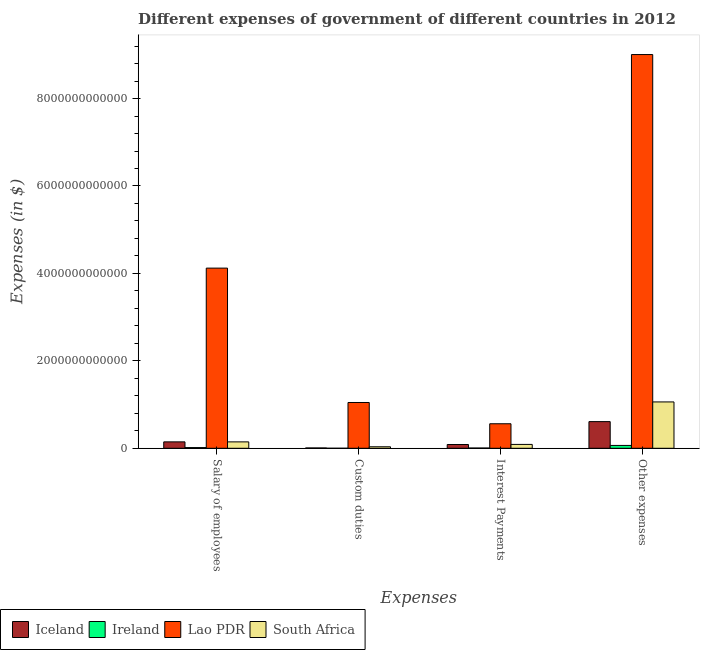How many different coloured bars are there?
Keep it short and to the point. 4. How many groups of bars are there?
Offer a terse response. 4. Are the number of bars per tick equal to the number of legend labels?
Offer a terse response. Yes. What is the label of the 3rd group of bars from the left?
Give a very brief answer. Interest Payments. What is the amount spent on other expenses in Iceland?
Keep it short and to the point. 6.10e+11. Across all countries, what is the maximum amount spent on custom duties?
Offer a terse response. 1.05e+12. Across all countries, what is the minimum amount spent on other expenses?
Offer a very short reply. 6.51e+1. In which country was the amount spent on salary of employees maximum?
Provide a short and direct response. Lao PDR. In which country was the amount spent on interest payments minimum?
Your answer should be very brief. Ireland. What is the total amount spent on custom duties in the graph?
Give a very brief answer. 1.09e+12. What is the difference between the amount spent on custom duties in Iceland and that in Lao PDR?
Provide a short and direct response. -1.04e+12. What is the difference between the amount spent on salary of employees in Iceland and the amount spent on custom duties in Lao PDR?
Offer a terse response. -9.00e+11. What is the average amount spent on other expenses per country?
Provide a short and direct response. 2.69e+12. What is the difference between the amount spent on other expenses and amount spent on custom duties in South Africa?
Your answer should be compact. 1.03e+12. What is the ratio of the amount spent on salary of employees in Lao PDR to that in Iceland?
Offer a very short reply. 28.06. Is the amount spent on other expenses in Iceland less than that in Ireland?
Provide a short and direct response. No. Is the difference between the amount spent on other expenses in Iceland and Ireland greater than the difference between the amount spent on custom duties in Iceland and Ireland?
Give a very brief answer. Yes. What is the difference between the highest and the second highest amount spent on interest payments?
Give a very brief answer. 4.72e+11. What is the difference between the highest and the lowest amount spent on other expenses?
Provide a short and direct response. 8.94e+12. In how many countries, is the amount spent on other expenses greater than the average amount spent on other expenses taken over all countries?
Ensure brevity in your answer.  1. Is the sum of the amount spent on custom duties in Iceland and South Africa greater than the maximum amount spent on interest payments across all countries?
Your answer should be very brief. No. Is it the case that in every country, the sum of the amount spent on other expenses and amount spent on interest payments is greater than the sum of amount spent on salary of employees and amount spent on custom duties?
Your response must be concise. Yes. What does the 4th bar from the left in Interest Payments represents?
Ensure brevity in your answer.  South Africa. What does the 4th bar from the right in Salary of employees represents?
Offer a terse response. Iceland. How many bars are there?
Your response must be concise. 16. How many countries are there in the graph?
Your answer should be compact. 4. What is the difference between two consecutive major ticks on the Y-axis?
Your answer should be very brief. 2.00e+12. Are the values on the major ticks of Y-axis written in scientific E-notation?
Ensure brevity in your answer.  No. Where does the legend appear in the graph?
Provide a short and direct response. Bottom left. How many legend labels are there?
Offer a terse response. 4. What is the title of the graph?
Your answer should be compact. Different expenses of government of different countries in 2012. What is the label or title of the X-axis?
Your answer should be compact. Expenses. What is the label or title of the Y-axis?
Make the answer very short. Expenses (in $). What is the Expenses (in $) of Iceland in Salary of employees?
Your answer should be very brief. 1.47e+11. What is the Expenses (in $) in Ireland in Salary of employees?
Your answer should be compact. 1.60e+1. What is the Expenses (in $) of Lao PDR in Salary of employees?
Provide a short and direct response. 4.12e+12. What is the Expenses (in $) of South Africa in Salary of employees?
Make the answer very short. 1.47e+11. What is the Expenses (in $) in Iceland in Custom duties?
Ensure brevity in your answer.  7.68e+09. What is the Expenses (in $) of Ireland in Custom duties?
Ensure brevity in your answer.  3.74e+07. What is the Expenses (in $) of Lao PDR in Custom duties?
Ensure brevity in your answer.  1.05e+12. What is the Expenses (in $) of South Africa in Custom duties?
Your response must be concise. 3.44e+1. What is the Expenses (in $) of Iceland in Interest Payments?
Your answer should be compact. 8.62e+1. What is the Expenses (in $) of Ireland in Interest Payments?
Your answer should be very brief. 5.89e+09. What is the Expenses (in $) of Lao PDR in Interest Payments?
Provide a short and direct response. 5.61e+11. What is the Expenses (in $) in South Africa in Interest Payments?
Ensure brevity in your answer.  8.85e+1. What is the Expenses (in $) of Iceland in Other expenses?
Your answer should be compact. 6.10e+11. What is the Expenses (in $) of Ireland in Other expenses?
Your answer should be very brief. 6.51e+1. What is the Expenses (in $) of Lao PDR in Other expenses?
Ensure brevity in your answer.  9.01e+12. What is the Expenses (in $) in South Africa in Other expenses?
Offer a very short reply. 1.06e+12. Across all Expenses, what is the maximum Expenses (in $) of Iceland?
Your answer should be very brief. 6.10e+11. Across all Expenses, what is the maximum Expenses (in $) in Ireland?
Provide a short and direct response. 6.51e+1. Across all Expenses, what is the maximum Expenses (in $) in Lao PDR?
Make the answer very short. 9.01e+12. Across all Expenses, what is the maximum Expenses (in $) in South Africa?
Offer a very short reply. 1.06e+12. Across all Expenses, what is the minimum Expenses (in $) of Iceland?
Provide a short and direct response. 7.68e+09. Across all Expenses, what is the minimum Expenses (in $) of Ireland?
Your answer should be very brief. 3.74e+07. Across all Expenses, what is the minimum Expenses (in $) in Lao PDR?
Ensure brevity in your answer.  5.61e+11. Across all Expenses, what is the minimum Expenses (in $) in South Africa?
Your answer should be very brief. 3.44e+1. What is the total Expenses (in $) of Iceland in the graph?
Offer a terse response. 8.51e+11. What is the total Expenses (in $) of Ireland in the graph?
Make the answer very short. 8.71e+1. What is the total Expenses (in $) of Lao PDR in the graph?
Offer a terse response. 1.47e+13. What is the total Expenses (in $) of South Africa in the graph?
Offer a terse response. 1.33e+12. What is the difference between the Expenses (in $) in Iceland in Salary of employees and that in Custom duties?
Your response must be concise. 1.39e+11. What is the difference between the Expenses (in $) of Ireland in Salary of employees and that in Custom duties?
Your answer should be very brief. 1.60e+1. What is the difference between the Expenses (in $) of Lao PDR in Salary of employees and that in Custom duties?
Your answer should be very brief. 3.07e+12. What is the difference between the Expenses (in $) of South Africa in Salary of employees and that in Custom duties?
Your response must be concise. 1.12e+11. What is the difference between the Expenses (in $) in Iceland in Salary of employees and that in Interest Payments?
Make the answer very short. 6.07e+1. What is the difference between the Expenses (in $) in Ireland in Salary of employees and that in Interest Payments?
Provide a short and direct response. 1.02e+1. What is the difference between the Expenses (in $) of Lao PDR in Salary of employees and that in Interest Payments?
Provide a succinct answer. 3.56e+12. What is the difference between the Expenses (in $) of South Africa in Salary of employees and that in Interest Payments?
Offer a very short reply. 5.80e+1. What is the difference between the Expenses (in $) in Iceland in Salary of employees and that in Other expenses?
Provide a succinct answer. -4.63e+11. What is the difference between the Expenses (in $) in Ireland in Salary of employees and that in Other expenses?
Offer a very short reply. -4.91e+1. What is the difference between the Expenses (in $) in Lao PDR in Salary of employees and that in Other expenses?
Provide a short and direct response. -4.89e+12. What is the difference between the Expenses (in $) in South Africa in Salary of employees and that in Other expenses?
Offer a very short reply. -9.14e+11. What is the difference between the Expenses (in $) in Iceland in Custom duties and that in Interest Payments?
Provide a succinct answer. -7.85e+1. What is the difference between the Expenses (in $) in Ireland in Custom duties and that in Interest Payments?
Offer a very short reply. -5.85e+09. What is the difference between the Expenses (in $) of Lao PDR in Custom duties and that in Interest Payments?
Give a very brief answer. 4.86e+11. What is the difference between the Expenses (in $) of South Africa in Custom duties and that in Interest Payments?
Offer a very short reply. -5.41e+1. What is the difference between the Expenses (in $) in Iceland in Custom duties and that in Other expenses?
Your answer should be very brief. -6.02e+11. What is the difference between the Expenses (in $) of Ireland in Custom duties and that in Other expenses?
Offer a very short reply. -6.51e+1. What is the difference between the Expenses (in $) of Lao PDR in Custom duties and that in Other expenses?
Your answer should be compact. -7.96e+12. What is the difference between the Expenses (in $) in South Africa in Custom duties and that in Other expenses?
Your answer should be very brief. -1.03e+12. What is the difference between the Expenses (in $) of Iceland in Interest Payments and that in Other expenses?
Keep it short and to the point. -5.24e+11. What is the difference between the Expenses (in $) of Ireland in Interest Payments and that in Other expenses?
Provide a succinct answer. -5.92e+1. What is the difference between the Expenses (in $) of Lao PDR in Interest Payments and that in Other expenses?
Your answer should be compact. -8.45e+12. What is the difference between the Expenses (in $) of South Africa in Interest Payments and that in Other expenses?
Provide a succinct answer. -9.72e+11. What is the difference between the Expenses (in $) of Iceland in Salary of employees and the Expenses (in $) of Ireland in Custom duties?
Offer a very short reply. 1.47e+11. What is the difference between the Expenses (in $) of Iceland in Salary of employees and the Expenses (in $) of Lao PDR in Custom duties?
Offer a very short reply. -9.00e+11. What is the difference between the Expenses (in $) of Iceland in Salary of employees and the Expenses (in $) of South Africa in Custom duties?
Your answer should be very brief. 1.12e+11. What is the difference between the Expenses (in $) of Ireland in Salary of employees and the Expenses (in $) of Lao PDR in Custom duties?
Make the answer very short. -1.03e+12. What is the difference between the Expenses (in $) of Ireland in Salary of employees and the Expenses (in $) of South Africa in Custom duties?
Your answer should be compact. -1.83e+1. What is the difference between the Expenses (in $) of Lao PDR in Salary of employees and the Expenses (in $) of South Africa in Custom duties?
Keep it short and to the point. 4.09e+12. What is the difference between the Expenses (in $) of Iceland in Salary of employees and the Expenses (in $) of Ireland in Interest Payments?
Provide a short and direct response. 1.41e+11. What is the difference between the Expenses (in $) in Iceland in Salary of employees and the Expenses (in $) in Lao PDR in Interest Payments?
Offer a terse response. -4.14e+11. What is the difference between the Expenses (in $) in Iceland in Salary of employees and the Expenses (in $) in South Africa in Interest Payments?
Your response must be concise. 5.84e+1. What is the difference between the Expenses (in $) in Ireland in Salary of employees and the Expenses (in $) in Lao PDR in Interest Payments?
Offer a terse response. -5.45e+11. What is the difference between the Expenses (in $) in Ireland in Salary of employees and the Expenses (in $) in South Africa in Interest Payments?
Your response must be concise. -7.25e+1. What is the difference between the Expenses (in $) in Lao PDR in Salary of employees and the Expenses (in $) in South Africa in Interest Payments?
Keep it short and to the point. 4.03e+12. What is the difference between the Expenses (in $) in Iceland in Salary of employees and the Expenses (in $) in Ireland in Other expenses?
Your answer should be compact. 8.18e+1. What is the difference between the Expenses (in $) of Iceland in Salary of employees and the Expenses (in $) of Lao PDR in Other expenses?
Your answer should be compact. -8.86e+12. What is the difference between the Expenses (in $) in Iceland in Salary of employees and the Expenses (in $) in South Africa in Other expenses?
Offer a terse response. -9.14e+11. What is the difference between the Expenses (in $) of Ireland in Salary of employees and the Expenses (in $) of Lao PDR in Other expenses?
Provide a succinct answer. -8.99e+12. What is the difference between the Expenses (in $) in Ireland in Salary of employees and the Expenses (in $) in South Africa in Other expenses?
Make the answer very short. -1.04e+12. What is the difference between the Expenses (in $) of Lao PDR in Salary of employees and the Expenses (in $) of South Africa in Other expenses?
Your answer should be compact. 3.06e+12. What is the difference between the Expenses (in $) in Iceland in Custom duties and the Expenses (in $) in Ireland in Interest Payments?
Offer a terse response. 1.79e+09. What is the difference between the Expenses (in $) of Iceland in Custom duties and the Expenses (in $) of Lao PDR in Interest Payments?
Your response must be concise. -5.53e+11. What is the difference between the Expenses (in $) in Iceland in Custom duties and the Expenses (in $) in South Africa in Interest Payments?
Your answer should be compact. -8.08e+1. What is the difference between the Expenses (in $) of Ireland in Custom duties and the Expenses (in $) of Lao PDR in Interest Payments?
Offer a terse response. -5.61e+11. What is the difference between the Expenses (in $) in Ireland in Custom duties and the Expenses (in $) in South Africa in Interest Payments?
Keep it short and to the point. -8.85e+1. What is the difference between the Expenses (in $) of Lao PDR in Custom duties and the Expenses (in $) of South Africa in Interest Payments?
Your response must be concise. 9.59e+11. What is the difference between the Expenses (in $) of Iceland in Custom duties and the Expenses (in $) of Ireland in Other expenses?
Your answer should be compact. -5.74e+1. What is the difference between the Expenses (in $) in Iceland in Custom duties and the Expenses (in $) in Lao PDR in Other expenses?
Offer a terse response. -9.00e+12. What is the difference between the Expenses (in $) of Iceland in Custom duties and the Expenses (in $) of South Africa in Other expenses?
Give a very brief answer. -1.05e+12. What is the difference between the Expenses (in $) in Ireland in Custom duties and the Expenses (in $) in Lao PDR in Other expenses?
Offer a very short reply. -9.01e+12. What is the difference between the Expenses (in $) in Ireland in Custom duties and the Expenses (in $) in South Africa in Other expenses?
Your answer should be very brief. -1.06e+12. What is the difference between the Expenses (in $) of Lao PDR in Custom duties and the Expenses (in $) of South Africa in Other expenses?
Give a very brief answer. -1.31e+1. What is the difference between the Expenses (in $) in Iceland in Interest Payments and the Expenses (in $) in Ireland in Other expenses?
Provide a succinct answer. 2.11e+1. What is the difference between the Expenses (in $) of Iceland in Interest Payments and the Expenses (in $) of Lao PDR in Other expenses?
Offer a very short reply. -8.92e+12. What is the difference between the Expenses (in $) in Iceland in Interest Payments and the Expenses (in $) in South Africa in Other expenses?
Provide a succinct answer. -9.74e+11. What is the difference between the Expenses (in $) of Ireland in Interest Payments and the Expenses (in $) of Lao PDR in Other expenses?
Make the answer very short. -9.00e+12. What is the difference between the Expenses (in $) in Ireland in Interest Payments and the Expenses (in $) in South Africa in Other expenses?
Your answer should be compact. -1.05e+12. What is the difference between the Expenses (in $) in Lao PDR in Interest Payments and the Expenses (in $) in South Africa in Other expenses?
Offer a very short reply. -5.00e+11. What is the average Expenses (in $) in Iceland per Expenses?
Provide a short and direct response. 2.13e+11. What is the average Expenses (in $) of Ireland per Expenses?
Provide a short and direct response. 2.18e+1. What is the average Expenses (in $) in Lao PDR per Expenses?
Keep it short and to the point. 3.68e+12. What is the average Expenses (in $) in South Africa per Expenses?
Your response must be concise. 3.32e+11. What is the difference between the Expenses (in $) in Iceland and Expenses (in $) in Ireland in Salary of employees?
Offer a terse response. 1.31e+11. What is the difference between the Expenses (in $) in Iceland and Expenses (in $) in Lao PDR in Salary of employees?
Offer a very short reply. -3.97e+12. What is the difference between the Expenses (in $) in Iceland and Expenses (in $) in South Africa in Salary of employees?
Ensure brevity in your answer.  3.49e+08. What is the difference between the Expenses (in $) of Ireland and Expenses (in $) of Lao PDR in Salary of employees?
Offer a terse response. -4.11e+12. What is the difference between the Expenses (in $) in Ireland and Expenses (in $) in South Africa in Salary of employees?
Your answer should be very brief. -1.30e+11. What is the difference between the Expenses (in $) in Lao PDR and Expenses (in $) in South Africa in Salary of employees?
Make the answer very short. 3.97e+12. What is the difference between the Expenses (in $) of Iceland and Expenses (in $) of Ireland in Custom duties?
Provide a short and direct response. 7.64e+09. What is the difference between the Expenses (in $) in Iceland and Expenses (in $) in Lao PDR in Custom duties?
Make the answer very short. -1.04e+12. What is the difference between the Expenses (in $) in Iceland and Expenses (in $) in South Africa in Custom duties?
Your answer should be compact. -2.67e+1. What is the difference between the Expenses (in $) of Ireland and Expenses (in $) of Lao PDR in Custom duties?
Your answer should be compact. -1.05e+12. What is the difference between the Expenses (in $) of Ireland and Expenses (in $) of South Africa in Custom duties?
Provide a short and direct response. -3.44e+1. What is the difference between the Expenses (in $) of Lao PDR and Expenses (in $) of South Africa in Custom duties?
Give a very brief answer. 1.01e+12. What is the difference between the Expenses (in $) in Iceland and Expenses (in $) in Ireland in Interest Payments?
Give a very brief answer. 8.03e+1. What is the difference between the Expenses (in $) of Iceland and Expenses (in $) of Lao PDR in Interest Payments?
Offer a terse response. -4.75e+11. What is the difference between the Expenses (in $) of Iceland and Expenses (in $) of South Africa in Interest Payments?
Make the answer very short. -2.31e+09. What is the difference between the Expenses (in $) in Ireland and Expenses (in $) in Lao PDR in Interest Payments?
Offer a very short reply. -5.55e+11. What is the difference between the Expenses (in $) in Ireland and Expenses (in $) in South Africa in Interest Payments?
Offer a very short reply. -8.26e+1. What is the difference between the Expenses (in $) in Lao PDR and Expenses (in $) in South Africa in Interest Payments?
Ensure brevity in your answer.  4.72e+11. What is the difference between the Expenses (in $) of Iceland and Expenses (in $) of Ireland in Other expenses?
Give a very brief answer. 5.45e+11. What is the difference between the Expenses (in $) in Iceland and Expenses (in $) in Lao PDR in Other expenses?
Offer a very short reply. -8.40e+12. What is the difference between the Expenses (in $) of Iceland and Expenses (in $) of South Africa in Other expenses?
Offer a very short reply. -4.50e+11. What is the difference between the Expenses (in $) of Ireland and Expenses (in $) of Lao PDR in Other expenses?
Your response must be concise. -8.94e+12. What is the difference between the Expenses (in $) of Ireland and Expenses (in $) of South Africa in Other expenses?
Provide a succinct answer. -9.95e+11. What is the difference between the Expenses (in $) in Lao PDR and Expenses (in $) in South Africa in Other expenses?
Your answer should be very brief. 7.95e+12. What is the ratio of the Expenses (in $) of Iceland in Salary of employees to that in Custom duties?
Offer a terse response. 19.12. What is the ratio of the Expenses (in $) of Ireland in Salary of employees to that in Custom duties?
Ensure brevity in your answer.  428.47. What is the ratio of the Expenses (in $) of Lao PDR in Salary of employees to that in Custom duties?
Your answer should be very brief. 3.94. What is the ratio of the Expenses (in $) in South Africa in Salary of employees to that in Custom duties?
Give a very brief answer. 4.26. What is the ratio of the Expenses (in $) of Iceland in Salary of employees to that in Interest Payments?
Make the answer very short. 1.7. What is the ratio of the Expenses (in $) in Ireland in Salary of employees to that in Interest Payments?
Your answer should be very brief. 2.72. What is the ratio of the Expenses (in $) of Lao PDR in Salary of employees to that in Interest Payments?
Your answer should be compact. 7.35. What is the ratio of the Expenses (in $) of South Africa in Salary of employees to that in Interest Payments?
Keep it short and to the point. 1.66. What is the ratio of the Expenses (in $) in Iceland in Salary of employees to that in Other expenses?
Ensure brevity in your answer.  0.24. What is the ratio of the Expenses (in $) in Ireland in Salary of employees to that in Other expenses?
Ensure brevity in your answer.  0.25. What is the ratio of the Expenses (in $) of Lao PDR in Salary of employees to that in Other expenses?
Provide a short and direct response. 0.46. What is the ratio of the Expenses (in $) in South Africa in Salary of employees to that in Other expenses?
Your answer should be very brief. 0.14. What is the ratio of the Expenses (in $) of Iceland in Custom duties to that in Interest Payments?
Give a very brief answer. 0.09. What is the ratio of the Expenses (in $) of Ireland in Custom duties to that in Interest Payments?
Offer a terse response. 0.01. What is the ratio of the Expenses (in $) of Lao PDR in Custom duties to that in Interest Payments?
Your answer should be very brief. 1.87. What is the ratio of the Expenses (in $) of South Africa in Custom duties to that in Interest Payments?
Offer a very short reply. 0.39. What is the ratio of the Expenses (in $) of Iceland in Custom duties to that in Other expenses?
Make the answer very short. 0.01. What is the ratio of the Expenses (in $) in Ireland in Custom duties to that in Other expenses?
Your answer should be compact. 0. What is the ratio of the Expenses (in $) of Lao PDR in Custom duties to that in Other expenses?
Offer a terse response. 0.12. What is the ratio of the Expenses (in $) in South Africa in Custom duties to that in Other expenses?
Make the answer very short. 0.03. What is the ratio of the Expenses (in $) in Iceland in Interest Payments to that in Other expenses?
Your answer should be very brief. 0.14. What is the ratio of the Expenses (in $) of Ireland in Interest Payments to that in Other expenses?
Ensure brevity in your answer.  0.09. What is the ratio of the Expenses (in $) of Lao PDR in Interest Payments to that in Other expenses?
Keep it short and to the point. 0.06. What is the ratio of the Expenses (in $) of South Africa in Interest Payments to that in Other expenses?
Offer a very short reply. 0.08. What is the difference between the highest and the second highest Expenses (in $) in Iceland?
Provide a succinct answer. 4.63e+11. What is the difference between the highest and the second highest Expenses (in $) of Ireland?
Offer a very short reply. 4.91e+1. What is the difference between the highest and the second highest Expenses (in $) of Lao PDR?
Your answer should be compact. 4.89e+12. What is the difference between the highest and the second highest Expenses (in $) of South Africa?
Ensure brevity in your answer.  9.14e+11. What is the difference between the highest and the lowest Expenses (in $) of Iceland?
Your answer should be compact. 6.02e+11. What is the difference between the highest and the lowest Expenses (in $) of Ireland?
Your answer should be compact. 6.51e+1. What is the difference between the highest and the lowest Expenses (in $) in Lao PDR?
Your answer should be very brief. 8.45e+12. What is the difference between the highest and the lowest Expenses (in $) of South Africa?
Your answer should be very brief. 1.03e+12. 